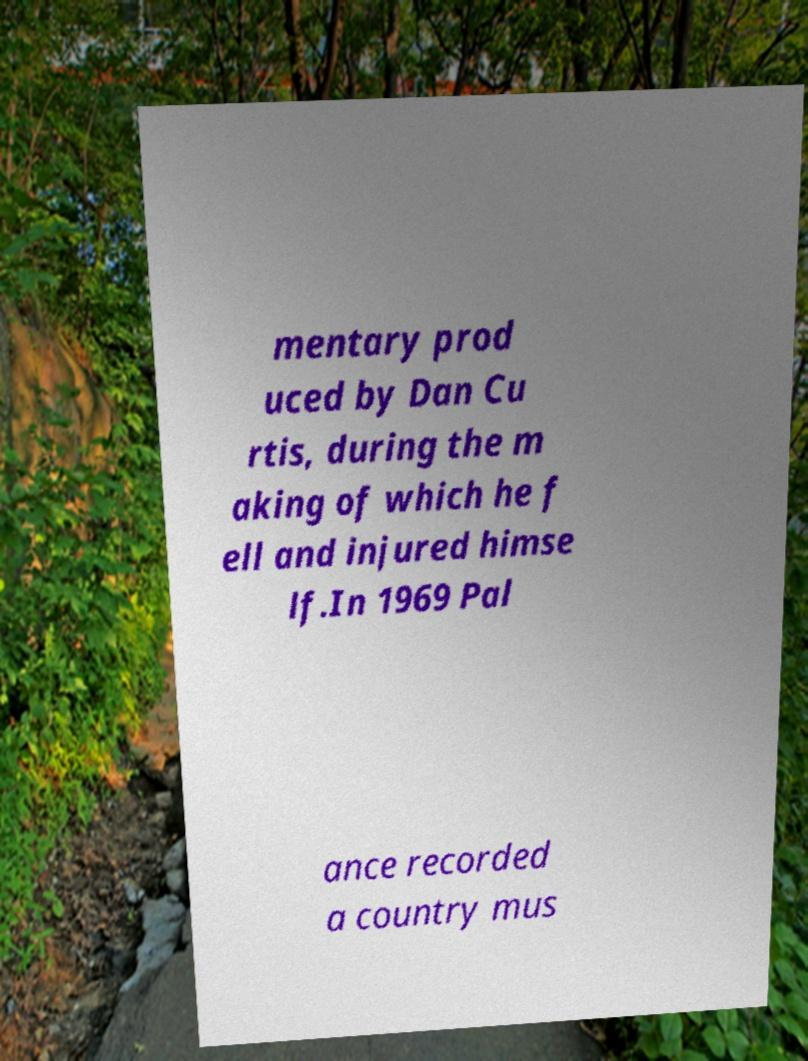There's text embedded in this image that I need extracted. Can you transcribe it verbatim? mentary prod uced by Dan Cu rtis, during the m aking of which he f ell and injured himse lf.In 1969 Pal ance recorded a country mus 